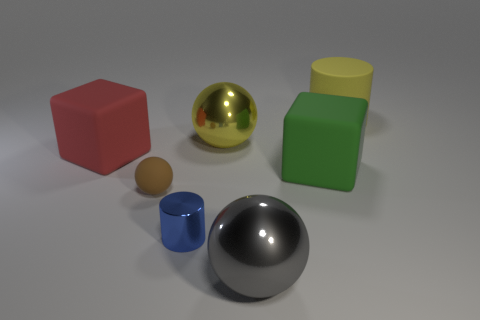Add 1 matte things. How many objects exist? 8 Subtract all yellow spheres. How many spheres are left? 2 Subtract all yellow cylinders. How many cylinders are left? 1 Subtract all cyan spheres. How many purple blocks are left? 0 Add 3 large cyan shiny cubes. How many large cyan shiny cubes exist? 3 Subtract 0 red spheres. How many objects are left? 7 Subtract all blocks. How many objects are left? 5 Subtract 3 balls. How many balls are left? 0 Subtract all yellow cylinders. Subtract all purple spheres. How many cylinders are left? 1 Subtract all large metallic things. Subtract all tiny objects. How many objects are left? 3 